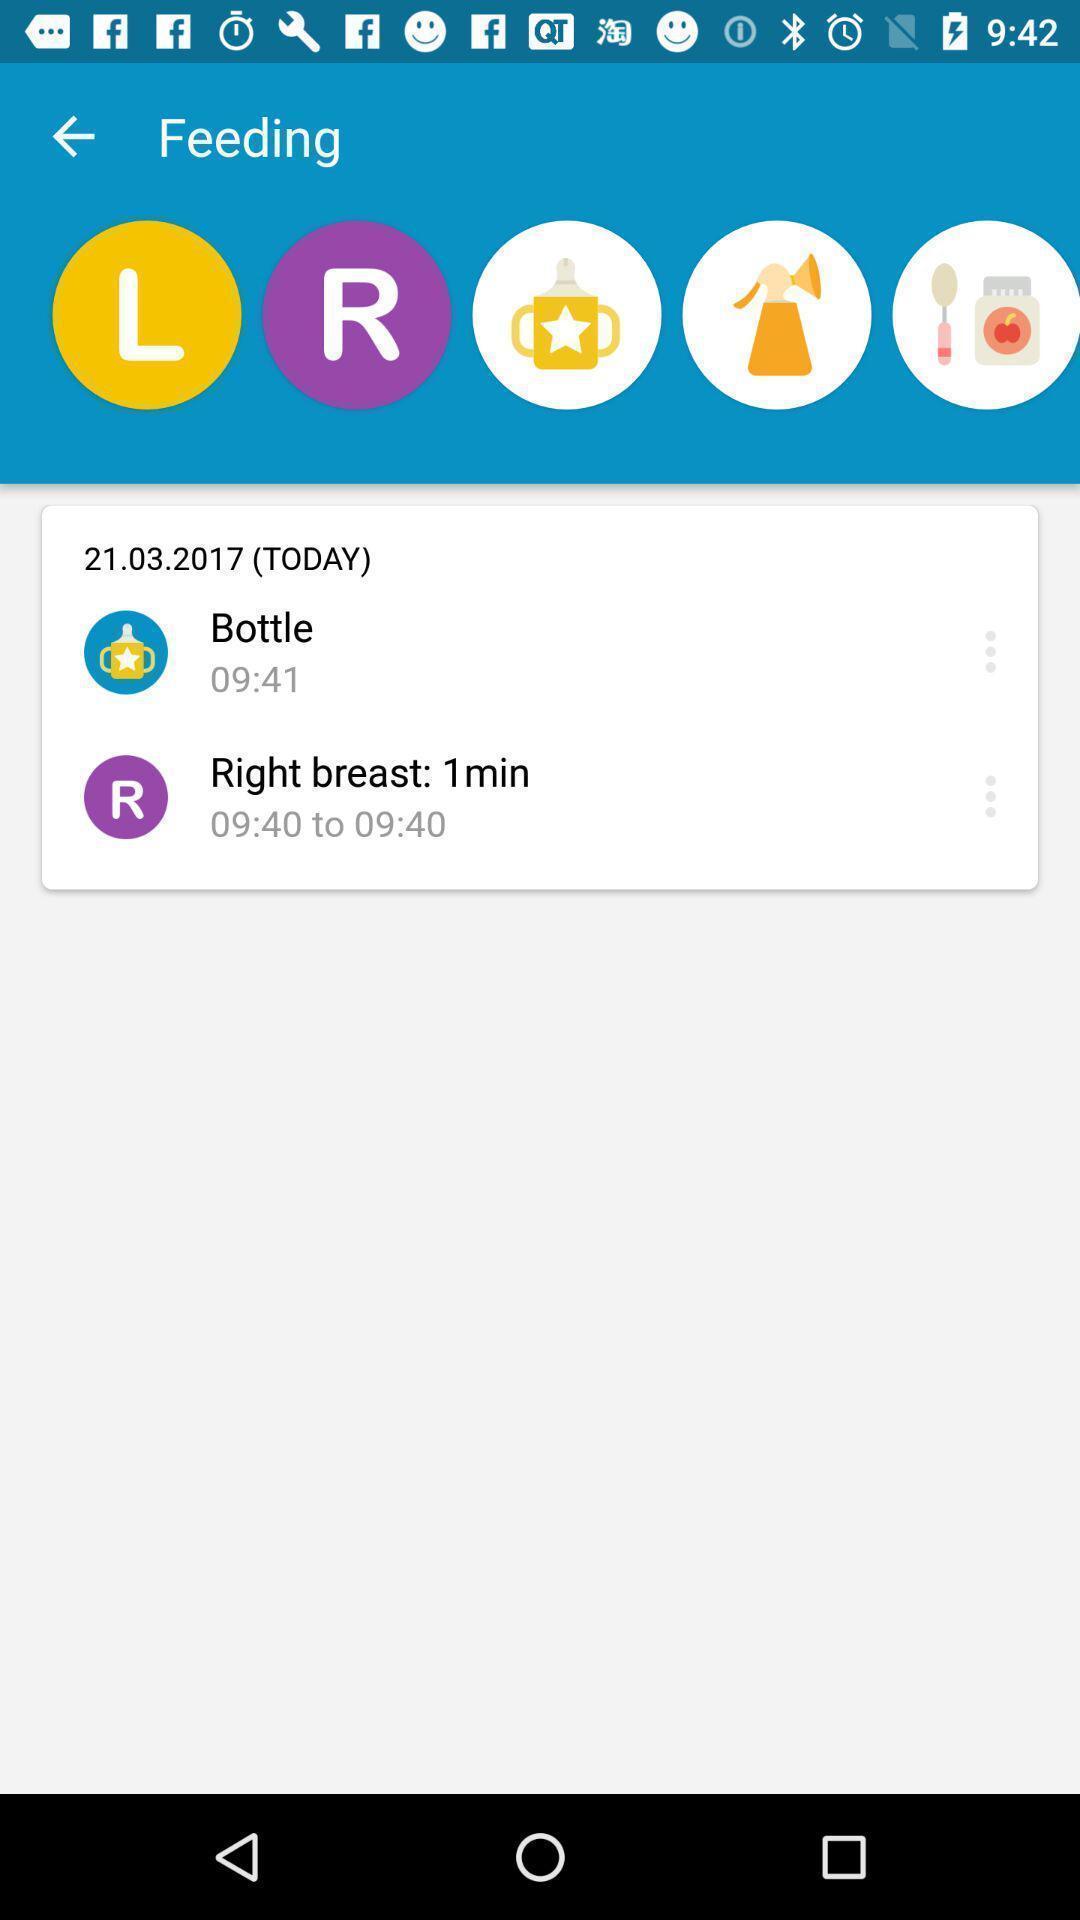Explain what's happening in this screen capture. Screen displaying multiple options in a nursing application. 